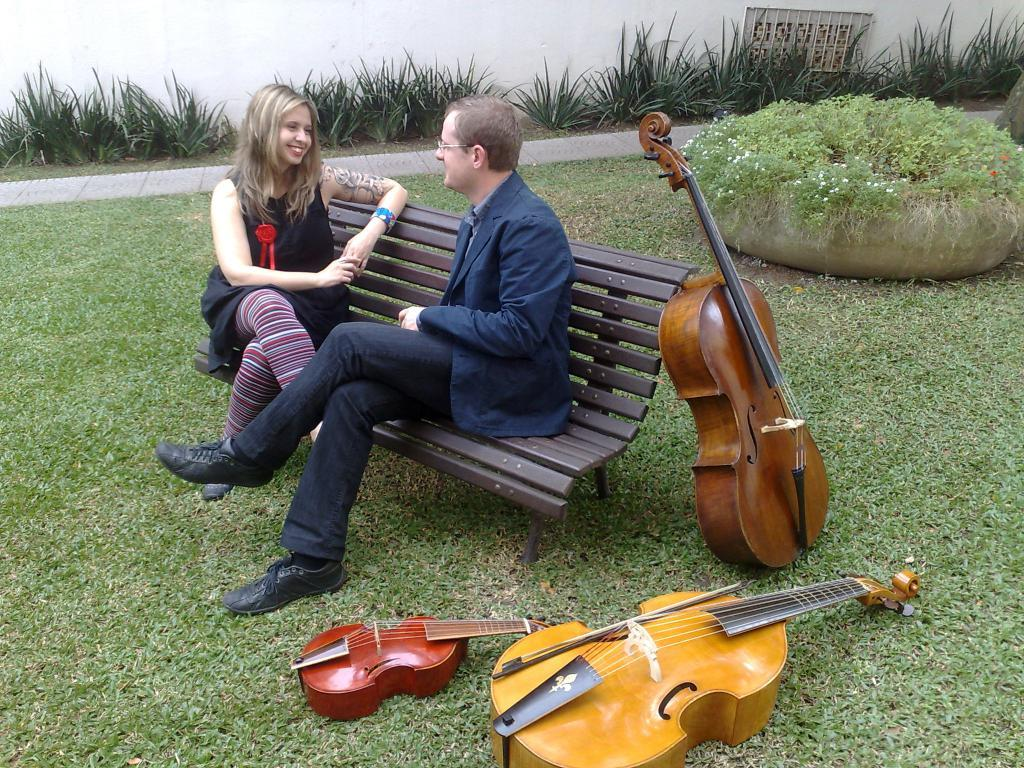Who can be seen in the image? There is a man and a woman in the image. What are they doing in the image? They are sitting on a bench. What objects are on the grass near them? There are three guitars on the grass. What can be seen in the background of the image? There are plants and a wall in the background of the image. Can you see an airplane flying over the wall in the image? There is no airplane visible in the image. What type of seed is being planted by the man and woman in the image? There is no seed planting activity depicted in the image. 